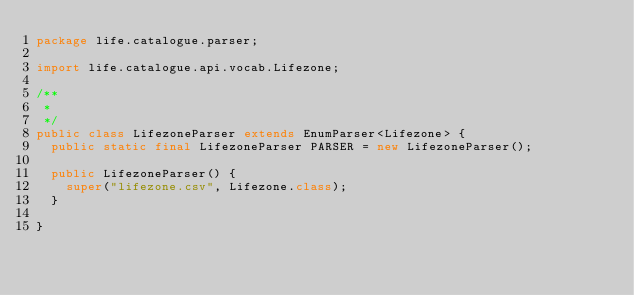Convert code to text. <code><loc_0><loc_0><loc_500><loc_500><_Java_>package life.catalogue.parser;

import life.catalogue.api.vocab.Lifezone;

/**
 *
 */
public class LifezoneParser extends EnumParser<Lifezone> {
  public static final LifezoneParser PARSER = new LifezoneParser();
  
  public LifezoneParser() {
    super("lifezone.csv", Lifezone.class);
  }
  
}
</code> 